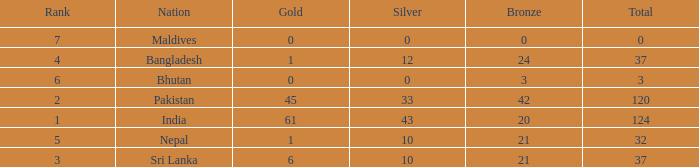Which Gold has a Nation of sri lanka, and a Silver smaller than 10? None. 